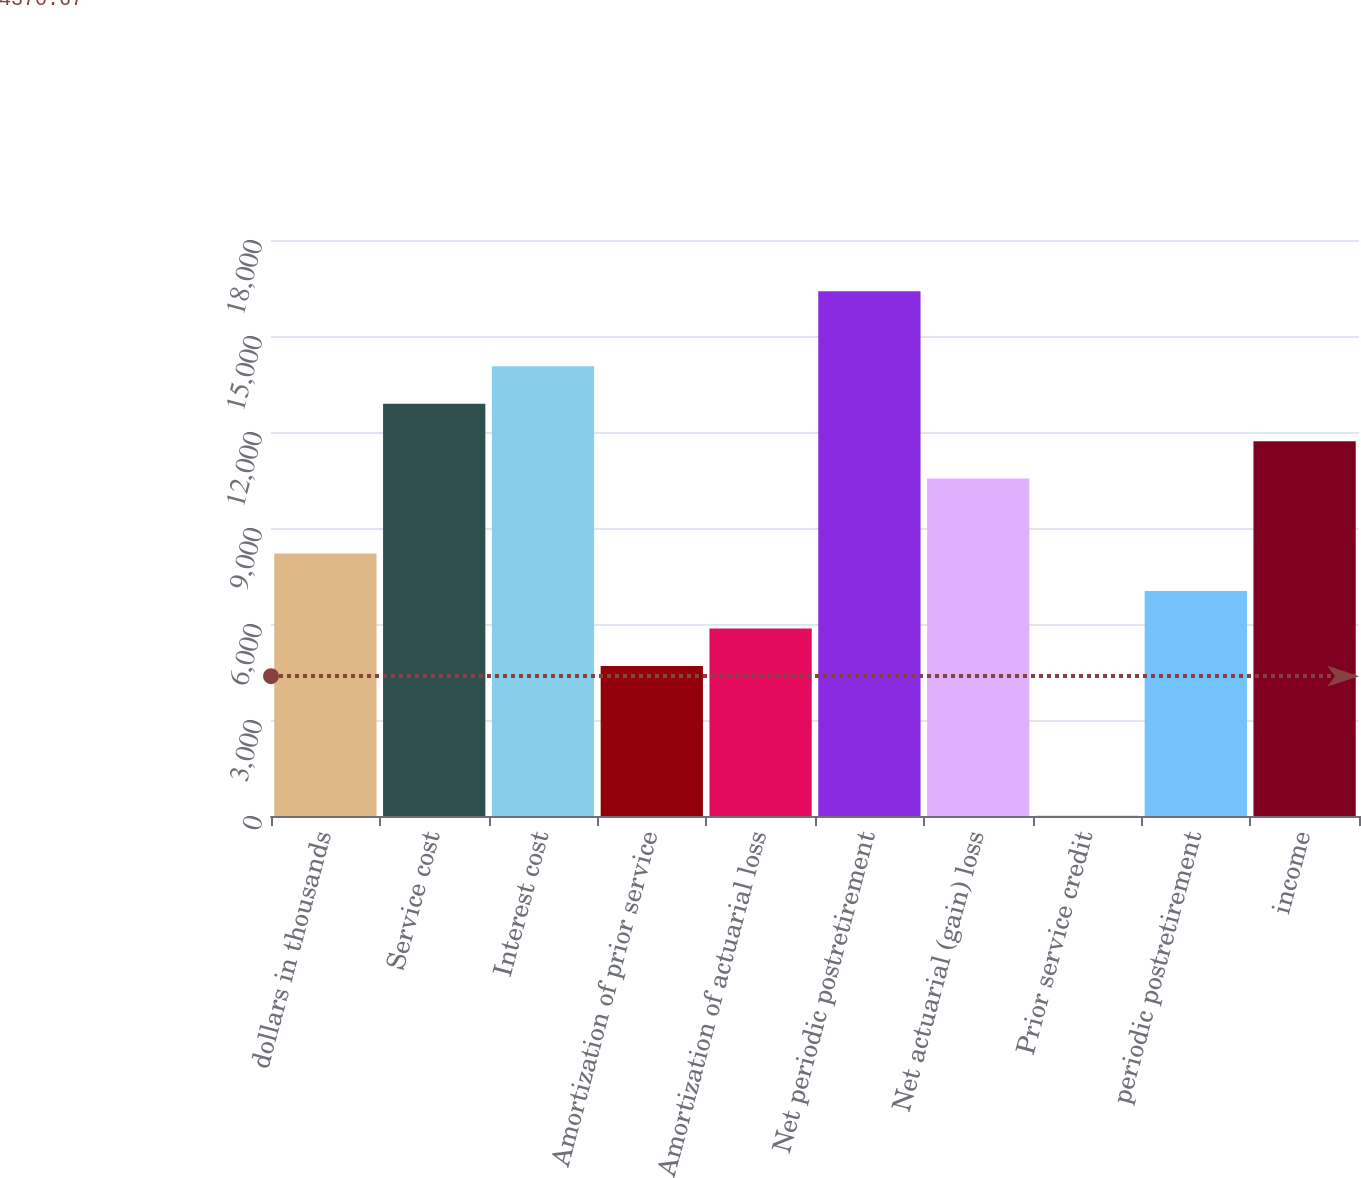Convert chart. <chart><loc_0><loc_0><loc_500><loc_500><bar_chart><fcel>dollars in thousands<fcel>Service cost<fcel>Interest cost<fcel>Amortization of prior service<fcel>Amortization of actuarial loss<fcel>Net periodic postretirement<fcel>Net actuarial (gain) loss<fcel>Prior service credit<fcel>periodic postretirement<fcel>income<nl><fcel>8201.05<fcel>12885<fcel>14056<fcel>4688.05<fcel>5859.05<fcel>16398<fcel>10543<fcel>4.05<fcel>7030.05<fcel>11714<nl></chart> 